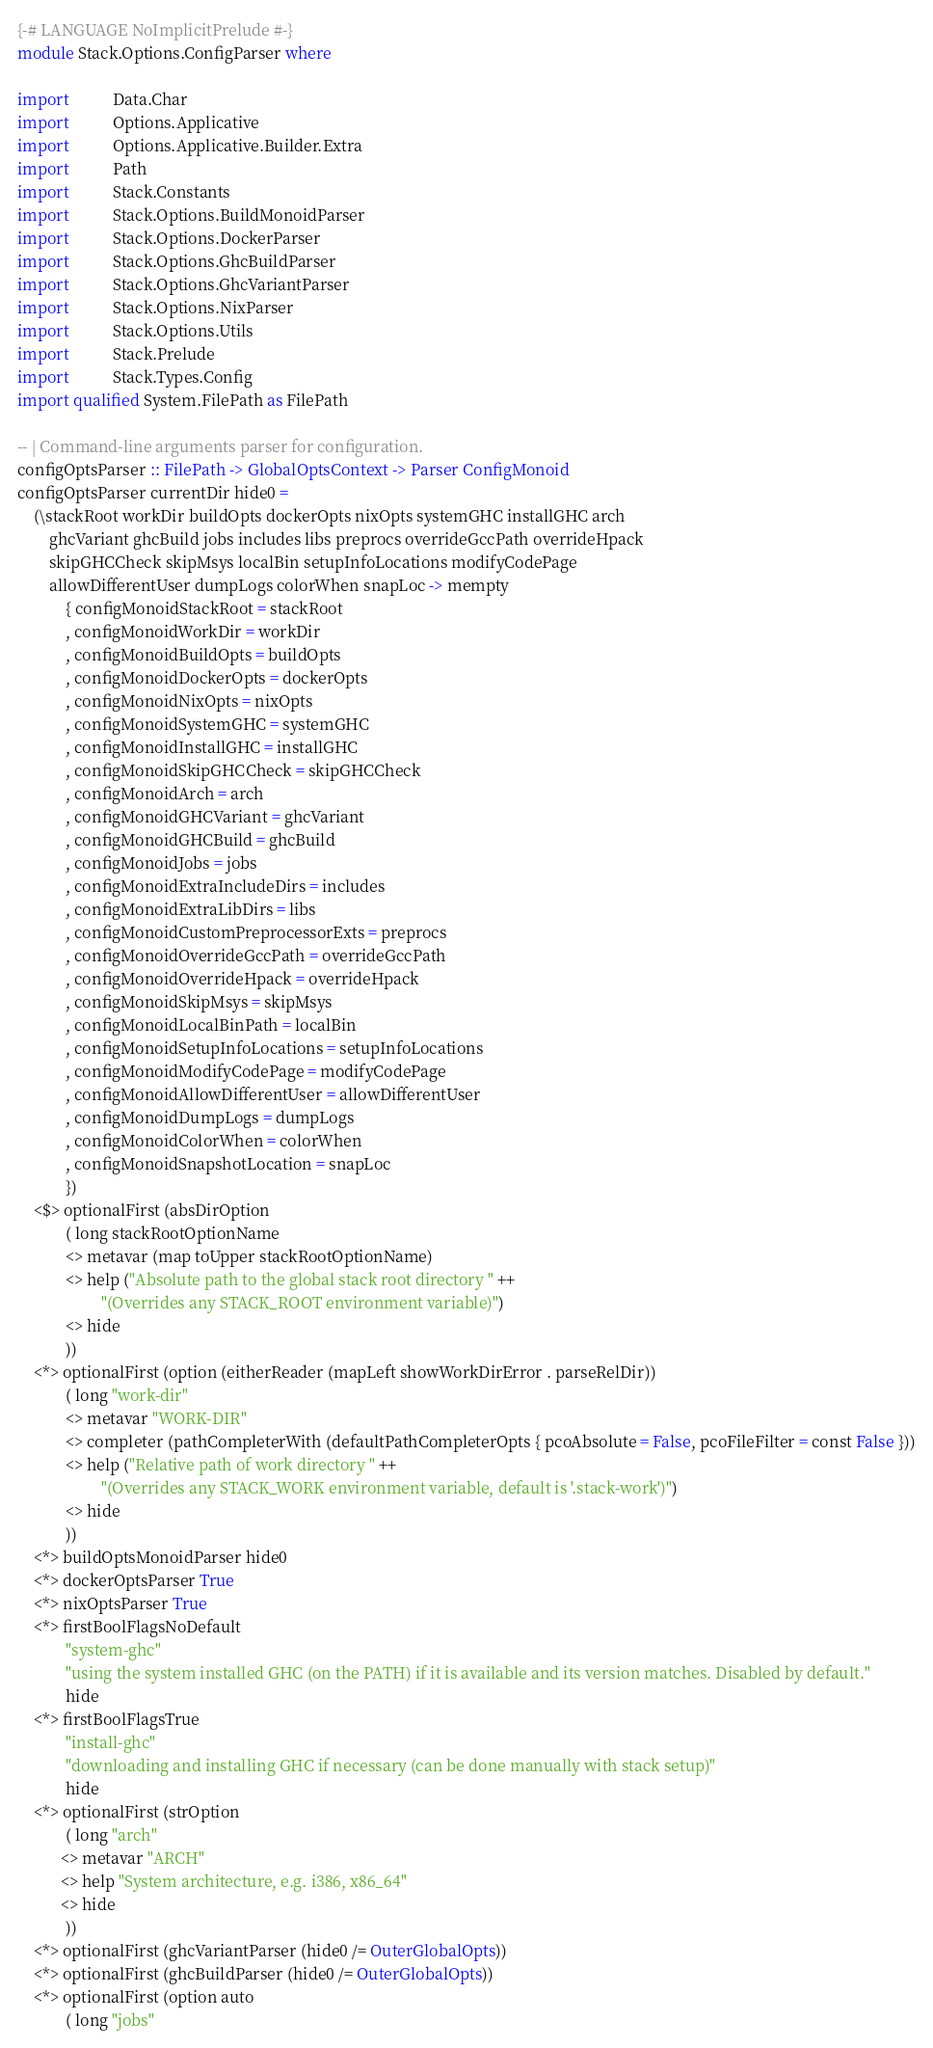<code> <loc_0><loc_0><loc_500><loc_500><_Haskell_>{-# LANGUAGE NoImplicitPrelude #-}
module Stack.Options.ConfigParser where

import           Data.Char
import           Options.Applicative
import           Options.Applicative.Builder.Extra
import           Path
import           Stack.Constants
import           Stack.Options.BuildMonoidParser
import           Stack.Options.DockerParser
import           Stack.Options.GhcBuildParser
import           Stack.Options.GhcVariantParser
import           Stack.Options.NixParser
import           Stack.Options.Utils
import           Stack.Prelude
import           Stack.Types.Config
import qualified System.FilePath as FilePath

-- | Command-line arguments parser for configuration.
configOptsParser :: FilePath -> GlobalOptsContext -> Parser ConfigMonoid
configOptsParser currentDir hide0 =
    (\stackRoot workDir buildOpts dockerOpts nixOpts systemGHC installGHC arch
        ghcVariant ghcBuild jobs includes libs preprocs overrideGccPath overrideHpack
        skipGHCCheck skipMsys localBin setupInfoLocations modifyCodePage
        allowDifferentUser dumpLogs colorWhen snapLoc -> mempty
            { configMonoidStackRoot = stackRoot
            , configMonoidWorkDir = workDir
            , configMonoidBuildOpts = buildOpts
            , configMonoidDockerOpts = dockerOpts
            , configMonoidNixOpts = nixOpts
            , configMonoidSystemGHC = systemGHC
            , configMonoidInstallGHC = installGHC
            , configMonoidSkipGHCCheck = skipGHCCheck
            , configMonoidArch = arch
            , configMonoidGHCVariant = ghcVariant
            , configMonoidGHCBuild = ghcBuild
            , configMonoidJobs = jobs
            , configMonoidExtraIncludeDirs = includes
            , configMonoidExtraLibDirs = libs
            , configMonoidCustomPreprocessorExts = preprocs
            , configMonoidOverrideGccPath = overrideGccPath
            , configMonoidOverrideHpack = overrideHpack
            , configMonoidSkipMsys = skipMsys
            , configMonoidLocalBinPath = localBin
            , configMonoidSetupInfoLocations = setupInfoLocations
            , configMonoidModifyCodePage = modifyCodePage
            , configMonoidAllowDifferentUser = allowDifferentUser
            , configMonoidDumpLogs = dumpLogs
            , configMonoidColorWhen = colorWhen
            , configMonoidSnapshotLocation = snapLoc
            })
    <$> optionalFirst (absDirOption
            ( long stackRootOptionName
            <> metavar (map toUpper stackRootOptionName)
            <> help ("Absolute path to the global stack root directory " ++
                     "(Overrides any STACK_ROOT environment variable)")
            <> hide
            ))
    <*> optionalFirst (option (eitherReader (mapLeft showWorkDirError . parseRelDir))
            ( long "work-dir"
            <> metavar "WORK-DIR"
            <> completer (pathCompleterWith (defaultPathCompleterOpts { pcoAbsolute = False, pcoFileFilter = const False }))
            <> help ("Relative path of work directory " ++
                     "(Overrides any STACK_WORK environment variable, default is '.stack-work')")
            <> hide
            ))
    <*> buildOptsMonoidParser hide0
    <*> dockerOptsParser True
    <*> nixOptsParser True
    <*> firstBoolFlagsNoDefault
            "system-ghc"
            "using the system installed GHC (on the PATH) if it is available and its version matches. Disabled by default."
            hide
    <*> firstBoolFlagsTrue
            "install-ghc"
            "downloading and installing GHC if necessary (can be done manually with stack setup)"
            hide
    <*> optionalFirst (strOption
            ( long "arch"
           <> metavar "ARCH"
           <> help "System architecture, e.g. i386, x86_64"
           <> hide
            ))
    <*> optionalFirst (ghcVariantParser (hide0 /= OuterGlobalOpts))
    <*> optionalFirst (ghcBuildParser (hide0 /= OuterGlobalOpts))
    <*> optionalFirst (option auto
            ( long "jobs"</code> 